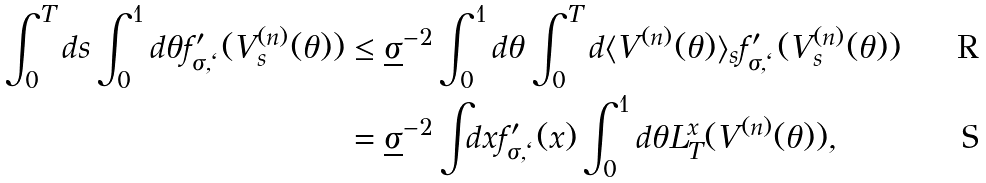<formula> <loc_0><loc_0><loc_500><loc_500>\int _ { 0 } ^ { T } d s \int _ { 0 } ^ { 1 } d \theta f ^ { \prime } _ { \sigma , \ell } ( V _ { s } ^ { ( n ) } ( \theta ) ) & \leq \underline { \sigma } ^ { - 2 } \int _ { 0 } ^ { 1 } d \theta \int _ { 0 } ^ { T } d \langle V ^ { ( n ) } ( \theta ) \rangle _ { s } f ^ { \prime } _ { \sigma , \ell } ( V _ { s } ^ { ( n ) } ( \theta ) ) \\ & = \underline { \sigma } ^ { - 2 } \int _ { \real } d x f ^ { \prime } _ { \sigma , \ell } ( x ) \int _ { 0 } ^ { 1 } d \theta L _ { T } ^ { x } ( V ^ { ( n ) } ( \theta ) ) ,</formula> 